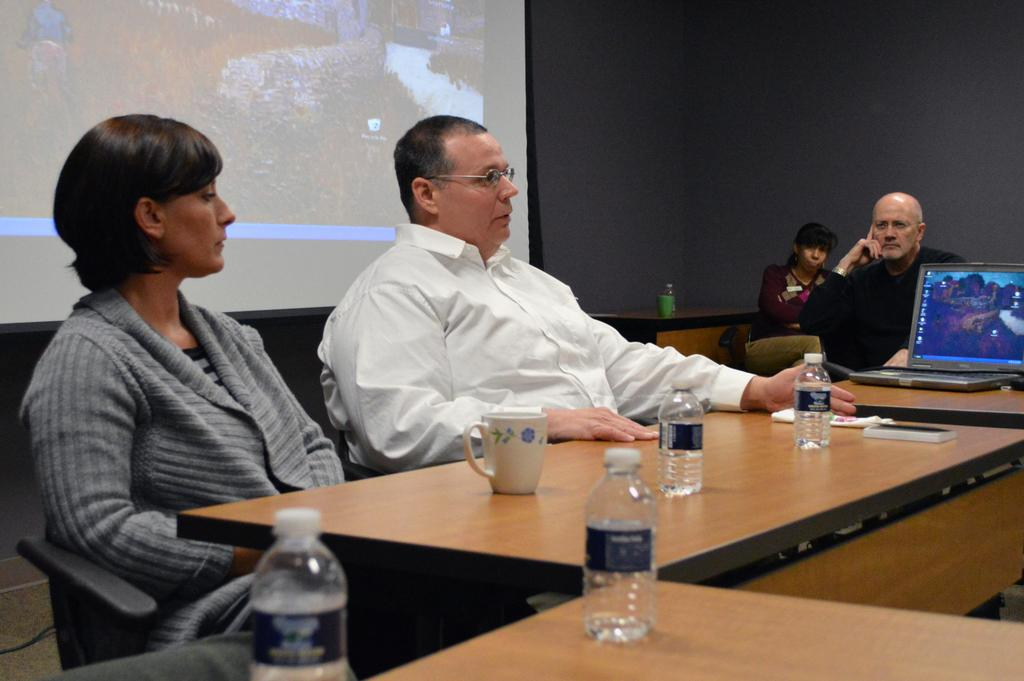How many people are in the image? There is a group of people in the image, but the exact number is not specified. What are the people doing in the image? The people are sitting on chairs in the image. What is on the table in front of the people? There is a glass, a bottle, and a laptop on the table in the image. What is at the back of the people? There is a screen projector at the back of the people in the image. Can you see any wounds on the people in the image? There is no mention of any wounds on the people in the image, and therefore it cannot be determined from the image. 